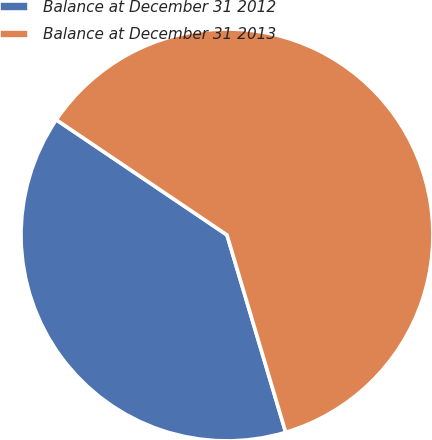Convert chart to OTSL. <chart><loc_0><loc_0><loc_500><loc_500><pie_chart><fcel>Balance at December 31 2012<fcel>Balance at December 31 2013<nl><fcel>39.05%<fcel>60.95%<nl></chart> 